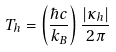Convert formula to latex. <formula><loc_0><loc_0><loc_500><loc_500>T _ { h } = \left ( \frac { \hbar { c } } { k _ { B } } \right ) \frac { | \kappa _ { h } | } { 2 \pi }</formula> 